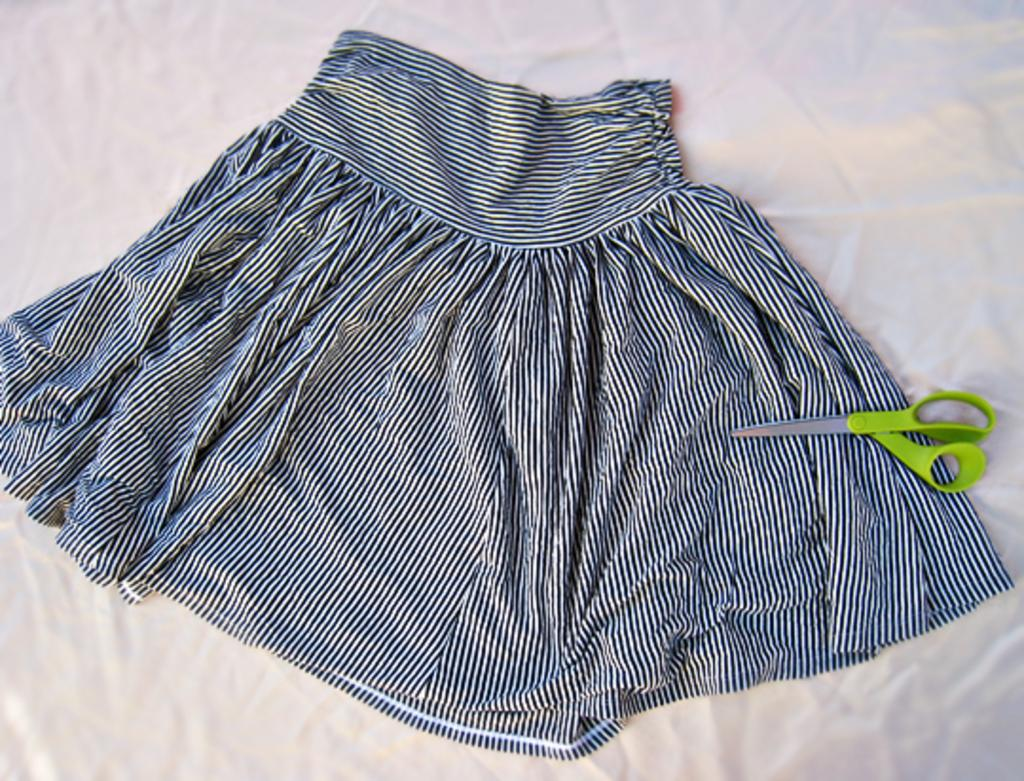What type of clothing is visible in the image? There is a skirt in the image. Where is the skirt placed in the image? The skirt is on a white surface. What object is placed on the skirt? There are scissors on the skirt. How many cats are sitting on the plate in the image? There are no cats or plates present in the image. 